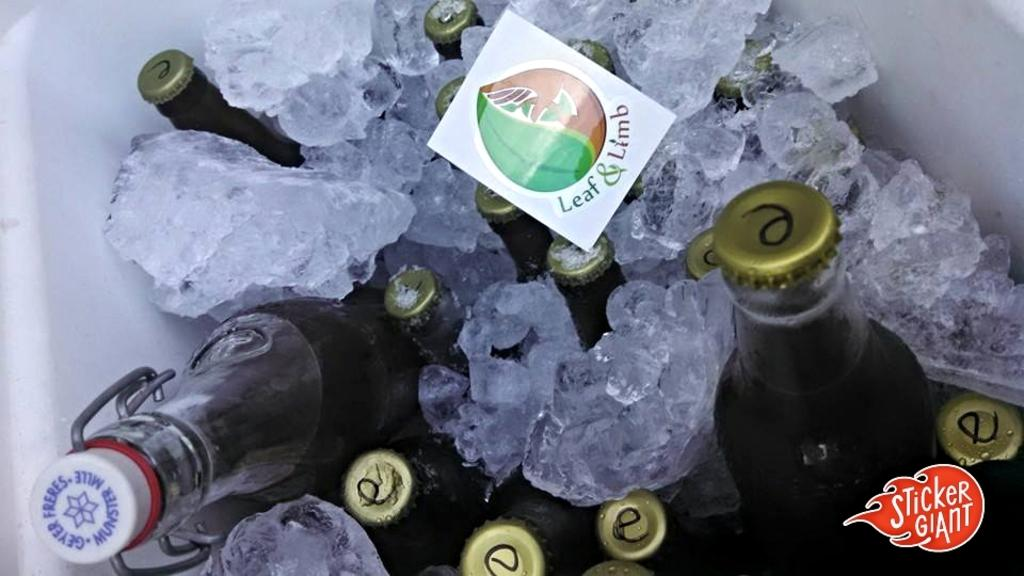<image>
Offer a succinct explanation of the picture presented. Beverages in bottles are in ice and a Leaf and Limb sticker is resting on top of some bottles. 